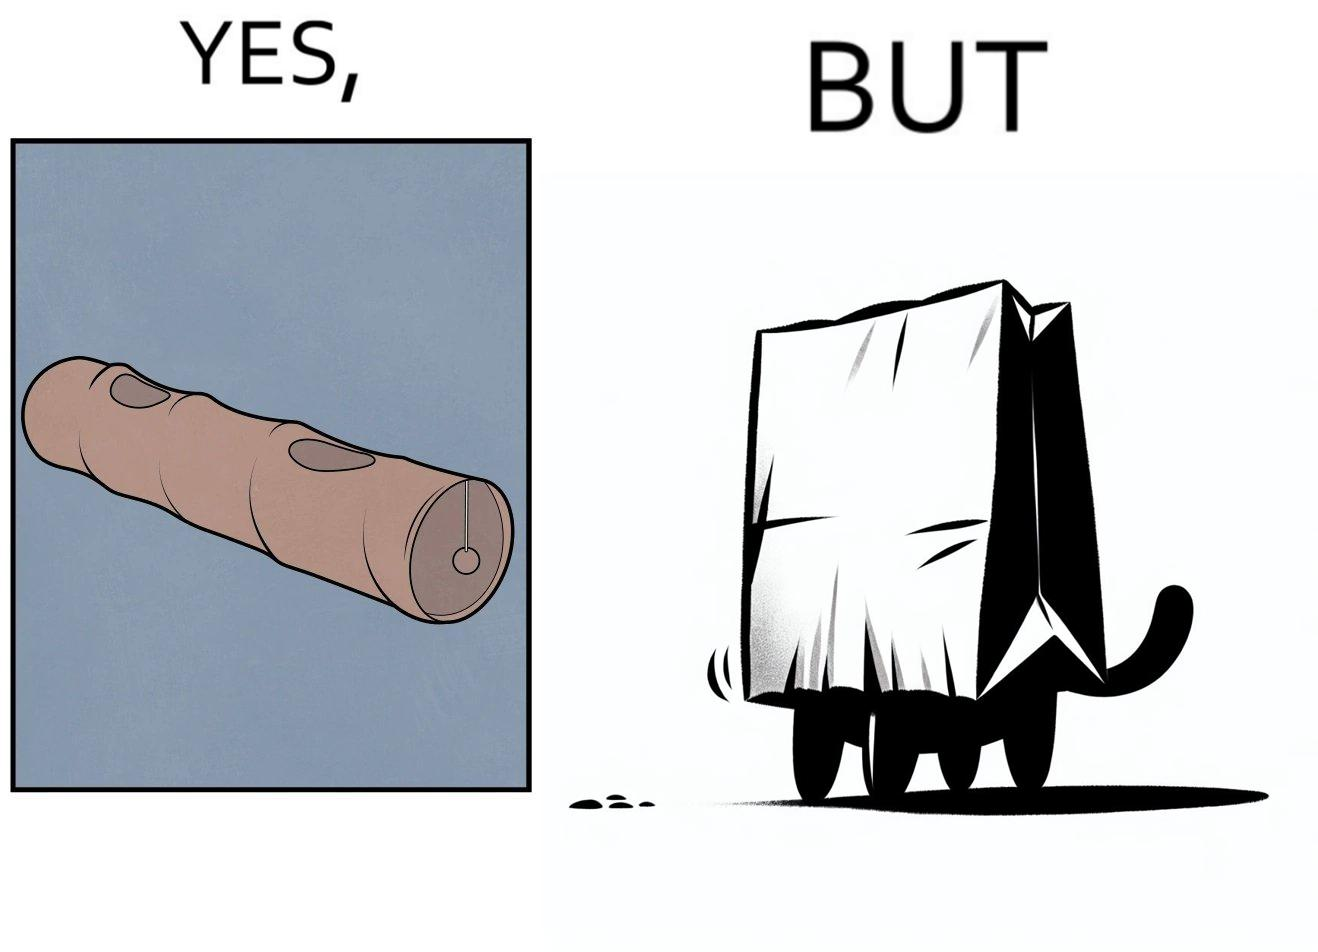Describe what you see in the left and right parts of this image. In the left part of the image: a long piece of cylinder with two circular holes over its surface and two holes at top and bottom and a hanging toy at one end In the right part of the image: an animal hiding its face in a paper bag, probably a cat or dog 